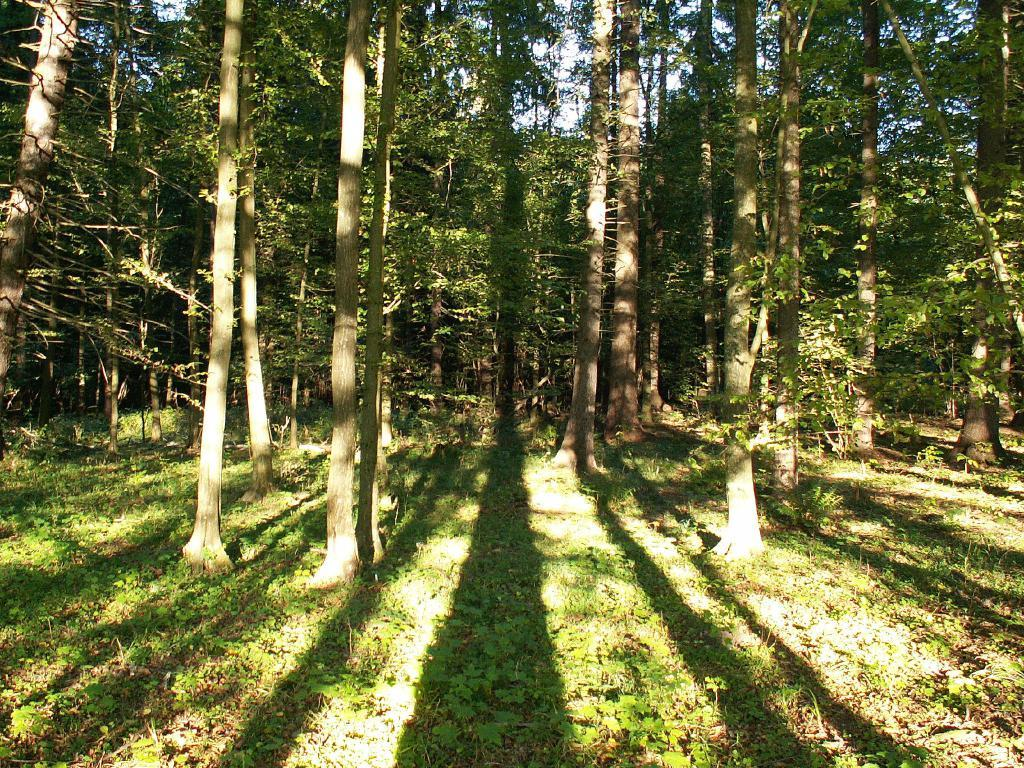What type of vegetation can be seen in the image? There are trees in the image. What part of the natural environment is visible in the background of the image? The sky is visible in the background of the image. What type of ground cover is present at the bottom of the image? There is grass at the bottom of the image. Where is the cave located in the image? There is no cave present in the image. What type of lace can be seen on the trees in the image? There is no lace present on the trees in the image. 